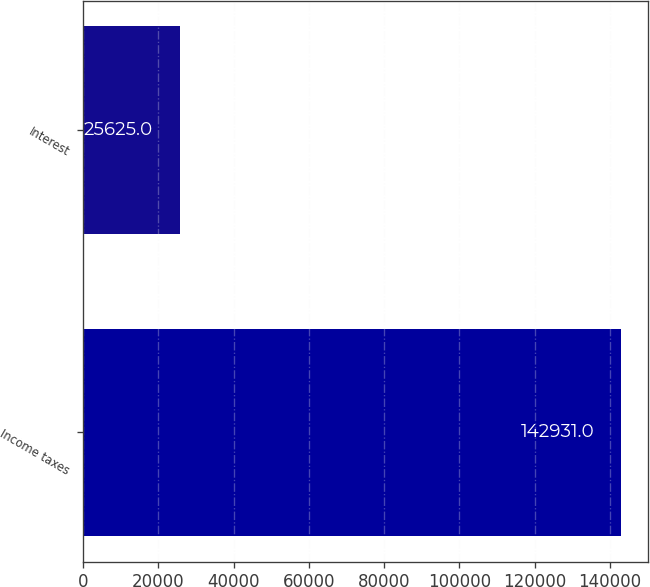Convert chart to OTSL. <chart><loc_0><loc_0><loc_500><loc_500><bar_chart><fcel>Income taxes<fcel>Interest<nl><fcel>142931<fcel>25625<nl></chart> 